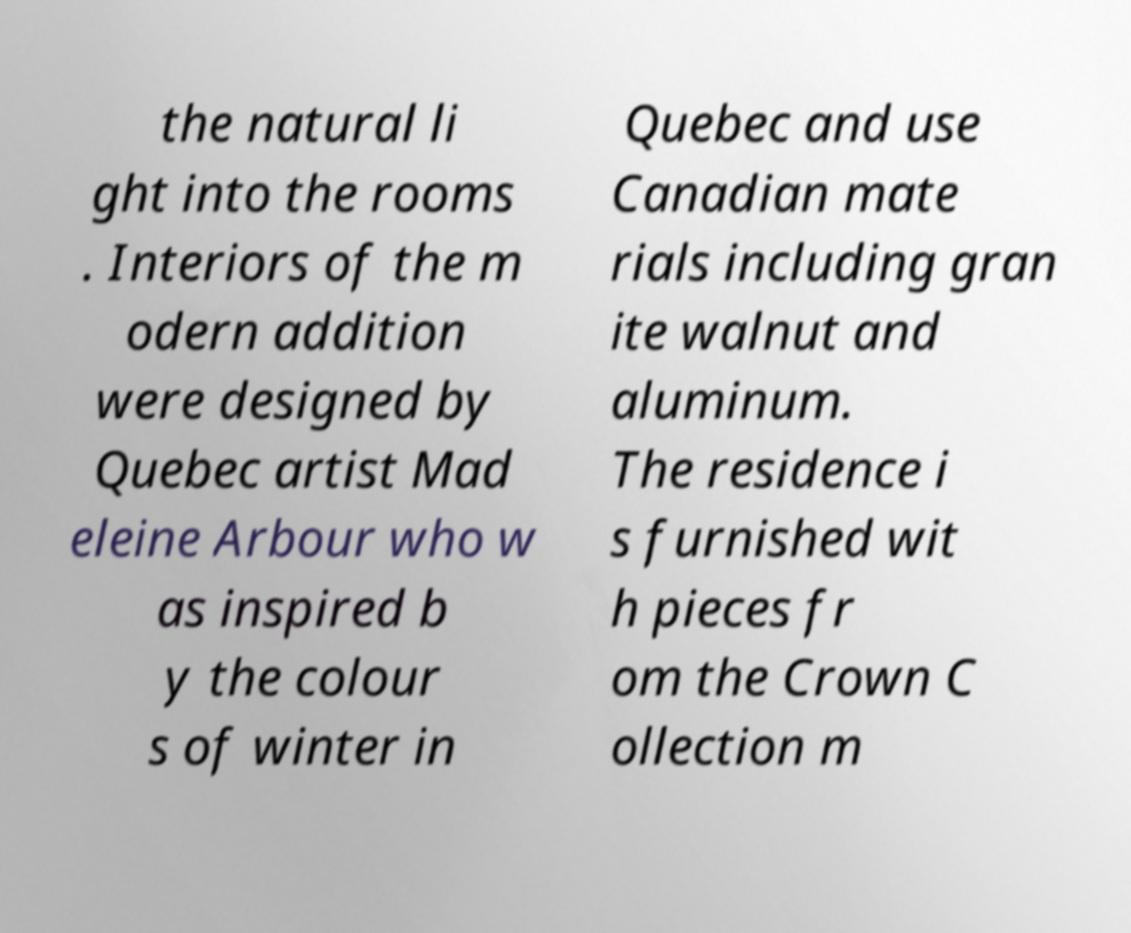For documentation purposes, I need the text within this image transcribed. Could you provide that? the natural li ght into the rooms . Interiors of the m odern addition were designed by Quebec artist Mad eleine Arbour who w as inspired b y the colour s of winter in Quebec and use Canadian mate rials including gran ite walnut and aluminum. The residence i s furnished wit h pieces fr om the Crown C ollection m 